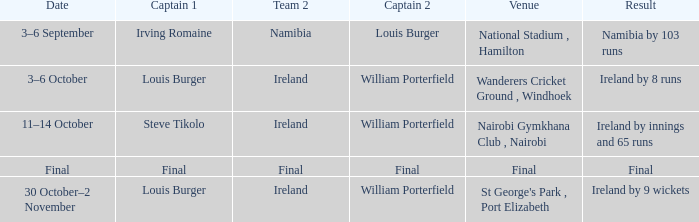Which Team 2 has a Captain 1 of final? Final. 